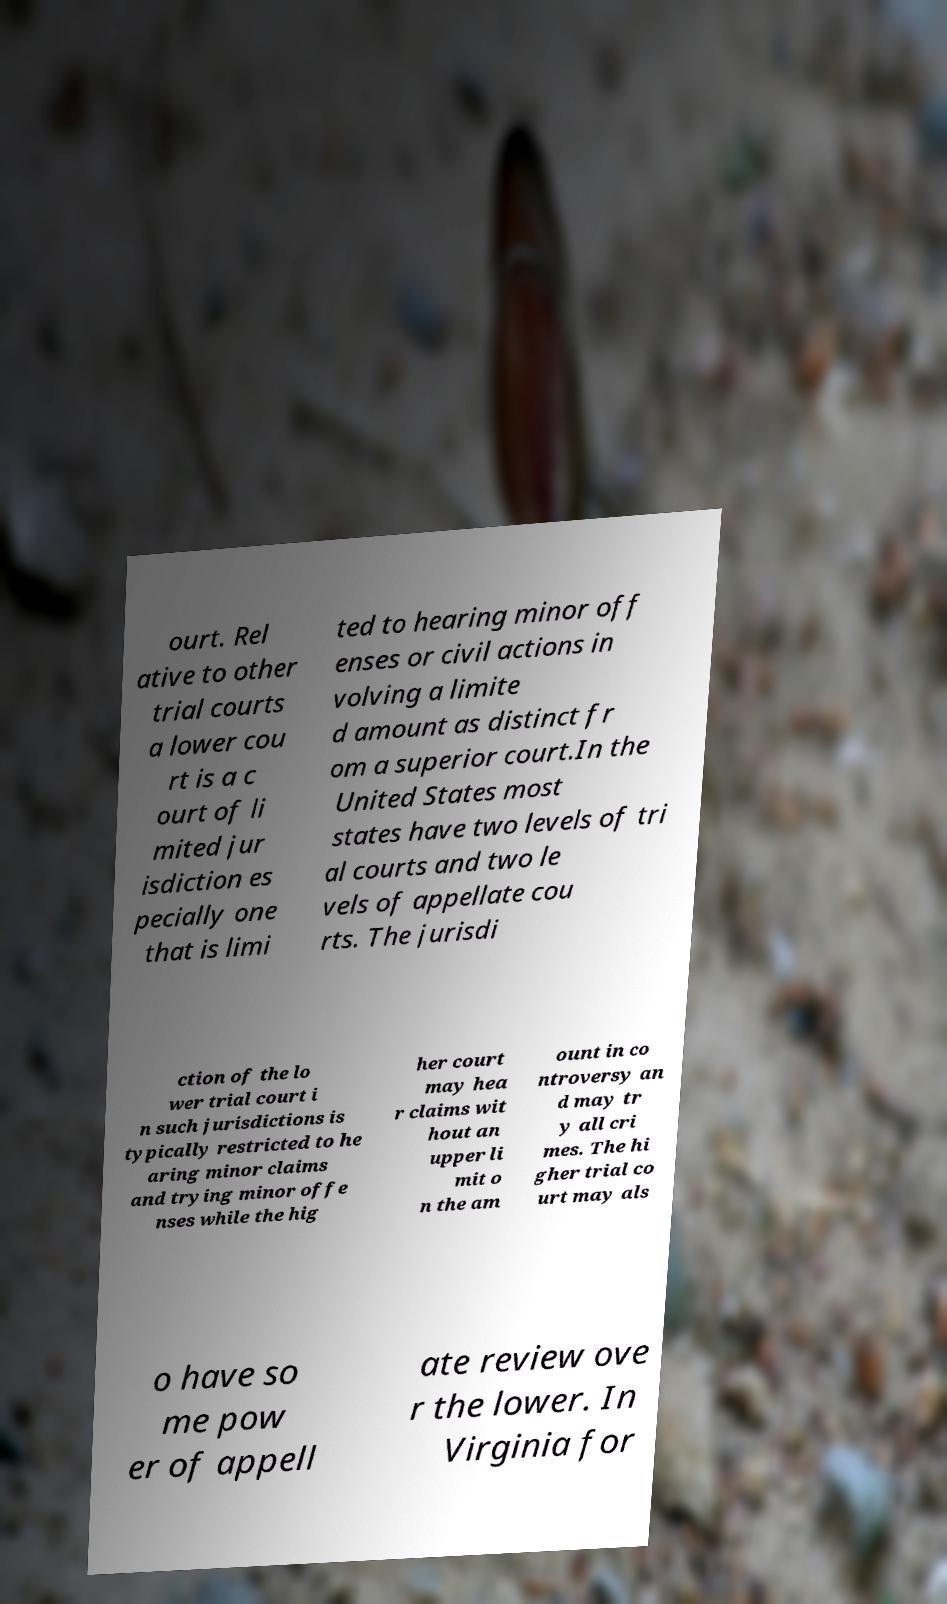For documentation purposes, I need the text within this image transcribed. Could you provide that? ourt. Rel ative to other trial courts a lower cou rt is a c ourt of li mited jur isdiction es pecially one that is limi ted to hearing minor off enses or civil actions in volving a limite d amount as distinct fr om a superior court.In the United States most states have two levels of tri al courts and two le vels of appellate cou rts. The jurisdi ction of the lo wer trial court i n such jurisdictions is typically restricted to he aring minor claims and trying minor offe nses while the hig her court may hea r claims wit hout an upper li mit o n the am ount in co ntroversy an d may tr y all cri mes. The hi gher trial co urt may als o have so me pow er of appell ate review ove r the lower. In Virginia for 